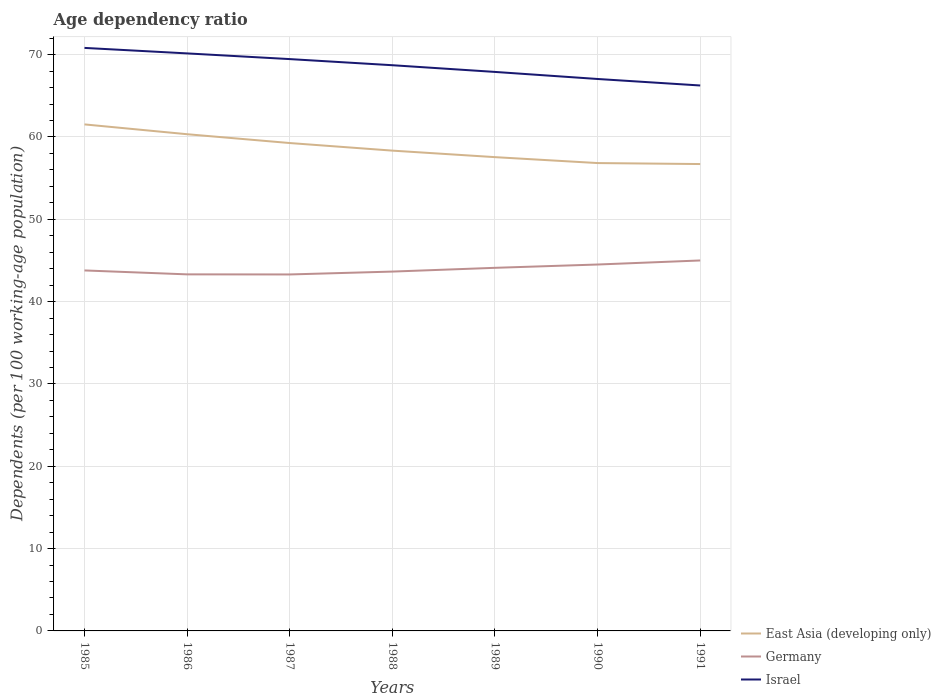How many different coloured lines are there?
Ensure brevity in your answer.  3. Does the line corresponding to Germany intersect with the line corresponding to Israel?
Give a very brief answer. No. Is the number of lines equal to the number of legend labels?
Give a very brief answer. Yes. Across all years, what is the maximum age dependency ratio in in Germany?
Your answer should be very brief. 43.3. In which year was the age dependency ratio in in East Asia (developing only) maximum?
Make the answer very short. 1991. What is the total age dependency ratio in in Germany in the graph?
Ensure brevity in your answer.  -1.2. What is the difference between the highest and the second highest age dependency ratio in in Germany?
Your response must be concise. 1.7. How many lines are there?
Keep it short and to the point. 3. What is the difference between two consecutive major ticks on the Y-axis?
Your response must be concise. 10. Does the graph contain any zero values?
Your answer should be very brief. No. Where does the legend appear in the graph?
Make the answer very short. Bottom right. How many legend labels are there?
Keep it short and to the point. 3. What is the title of the graph?
Keep it short and to the point. Age dependency ratio. Does "Low income" appear as one of the legend labels in the graph?
Offer a terse response. No. What is the label or title of the X-axis?
Offer a very short reply. Years. What is the label or title of the Y-axis?
Ensure brevity in your answer.  Dependents (per 100 working-age population). What is the Dependents (per 100 working-age population) of East Asia (developing only) in 1985?
Provide a short and direct response. 61.53. What is the Dependents (per 100 working-age population) of Germany in 1985?
Offer a very short reply. 43.79. What is the Dependents (per 100 working-age population) in Israel in 1985?
Your answer should be compact. 70.82. What is the Dependents (per 100 working-age population) of East Asia (developing only) in 1986?
Give a very brief answer. 60.33. What is the Dependents (per 100 working-age population) in Germany in 1986?
Your response must be concise. 43.31. What is the Dependents (per 100 working-age population) in Israel in 1986?
Your response must be concise. 70.15. What is the Dependents (per 100 working-age population) of East Asia (developing only) in 1987?
Provide a succinct answer. 59.26. What is the Dependents (per 100 working-age population) of Germany in 1987?
Keep it short and to the point. 43.3. What is the Dependents (per 100 working-age population) in Israel in 1987?
Your response must be concise. 69.46. What is the Dependents (per 100 working-age population) in East Asia (developing only) in 1988?
Provide a short and direct response. 58.34. What is the Dependents (per 100 working-age population) of Germany in 1988?
Your response must be concise. 43.65. What is the Dependents (per 100 working-age population) of Israel in 1988?
Keep it short and to the point. 68.72. What is the Dependents (per 100 working-age population) of East Asia (developing only) in 1989?
Provide a succinct answer. 57.55. What is the Dependents (per 100 working-age population) in Germany in 1989?
Provide a short and direct response. 44.11. What is the Dependents (per 100 working-age population) of Israel in 1989?
Provide a short and direct response. 67.9. What is the Dependents (per 100 working-age population) of East Asia (developing only) in 1990?
Offer a terse response. 56.83. What is the Dependents (per 100 working-age population) in Germany in 1990?
Your answer should be very brief. 44.51. What is the Dependents (per 100 working-age population) in Israel in 1990?
Provide a succinct answer. 67.04. What is the Dependents (per 100 working-age population) of East Asia (developing only) in 1991?
Give a very brief answer. 56.71. What is the Dependents (per 100 working-age population) in Germany in 1991?
Ensure brevity in your answer.  45. What is the Dependents (per 100 working-age population) of Israel in 1991?
Your answer should be compact. 66.26. Across all years, what is the maximum Dependents (per 100 working-age population) of East Asia (developing only)?
Keep it short and to the point. 61.53. Across all years, what is the maximum Dependents (per 100 working-age population) in Germany?
Provide a short and direct response. 45. Across all years, what is the maximum Dependents (per 100 working-age population) in Israel?
Keep it short and to the point. 70.82. Across all years, what is the minimum Dependents (per 100 working-age population) of East Asia (developing only)?
Your answer should be very brief. 56.71. Across all years, what is the minimum Dependents (per 100 working-age population) of Germany?
Ensure brevity in your answer.  43.3. Across all years, what is the minimum Dependents (per 100 working-age population) of Israel?
Ensure brevity in your answer.  66.26. What is the total Dependents (per 100 working-age population) of East Asia (developing only) in the graph?
Give a very brief answer. 410.56. What is the total Dependents (per 100 working-age population) in Germany in the graph?
Give a very brief answer. 307.66. What is the total Dependents (per 100 working-age population) of Israel in the graph?
Ensure brevity in your answer.  480.35. What is the difference between the Dependents (per 100 working-age population) in East Asia (developing only) in 1985 and that in 1986?
Offer a very short reply. 1.19. What is the difference between the Dependents (per 100 working-age population) of Germany in 1985 and that in 1986?
Provide a succinct answer. 0.48. What is the difference between the Dependents (per 100 working-age population) of Israel in 1985 and that in 1986?
Offer a terse response. 0.67. What is the difference between the Dependents (per 100 working-age population) in East Asia (developing only) in 1985 and that in 1987?
Your answer should be very brief. 2.26. What is the difference between the Dependents (per 100 working-age population) in Germany in 1985 and that in 1987?
Your response must be concise. 0.49. What is the difference between the Dependents (per 100 working-age population) in Israel in 1985 and that in 1987?
Provide a succinct answer. 1.36. What is the difference between the Dependents (per 100 working-age population) in East Asia (developing only) in 1985 and that in 1988?
Offer a very short reply. 3.19. What is the difference between the Dependents (per 100 working-age population) in Germany in 1985 and that in 1988?
Give a very brief answer. 0.14. What is the difference between the Dependents (per 100 working-age population) of Israel in 1985 and that in 1988?
Offer a very short reply. 2.1. What is the difference between the Dependents (per 100 working-age population) of East Asia (developing only) in 1985 and that in 1989?
Your answer should be very brief. 3.98. What is the difference between the Dependents (per 100 working-age population) in Germany in 1985 and that in 1989?
Your answer should be compact. -0.32. What is the difference between the Dependents (per 100 working-age population) in Israel in 1985 and that in 1989?
Offer a terse response. 2.92. What is the difference between the Dependents (per 100 working-age population) of East Asia (developing only) in 1985 and that in 1990?
Keep it short and to the point. 4.7. What is the difference between the Dependents (per 100 working-age population) in Germany in 1985 and that in 1990?
Provide a short and direct response. -0.72. What is the difference between the Dependents (per 100 working-age population) in Israel in 1985 and that in 1990?
Make the answer very short. 3.78. What is the difference between the Dependents (per 100 working-age population) of East Asia (developing only) in 1985 and that in 1991?
Provide a succinct answer. 4.81. What is the difference between the Dependents (per 100 working-age population) of Germany in 1985 and that in 1991?
Your answer should be compact. -1.21. What is the difference between the Dependents (per 100 working-age population) in Israel in 1985 and that in 1991?
Offer a terse response. 4.57. What is the difference between the Dependents (per 100 working-age population) in East Asia (developing only) in 1986 and that in 1987?
Offer a terse response. 1.07. What is the difference between the Dependents (per 100 working-age population) in Germany in 1986 and that in 1987?
Offer a very short reply. 0.01. What is the difference between the Dependents (per 100 working-age population) in Israel in 1986 and that in 1987?
Provide a succinct answer. 0.69. What is the difference between the Dependents (per 100 working-age population) of East Asia (developing only) in 1986 and that in 1988?
Make the answer very short. 1.99. What is the difference between the Dependents (per 100 working-age population) of Germany in 1986 and that in 1988?
Offer a terse response. -0.34. What is the difference between the Dependents (per 100 working-age population) in Israel in 1986 and that in 1988?
Make the answer very short. 1.44. What is the difference between the Dependents (per 100 working-age population) in East Asia (developing only) in 1986 and that in 1989?
Provide a succinct answer. 2.78. What is the difference between the Dependents (per 100 working-age population) of Germany in 1986 and that in 1989?
Provide a short and direct response. -0.8. What is the difference between the Dependents (per 100 working-age population) in Israel in 1986 and that in 1989?
Make the answer very short. 2.25. What is the difference between the Dependents (per 100 working-age population) of East Asia (developing only) in 1986 and that in 1990?
Your response must be concise. 3.5. What is the difference between the Dependents (per 100 working-age population) in Germany in 1986 and that in 1990?
Keep it short and to the point. -1.2. What is the difference between the Dependents (per 100 working-age population) in Israel in 1986 and that in 1990?
Ensure brevity in your answer.  3.11. What is the difference between the Dependents (per 100 working-age population) of East Asia (developing only) in 1986 and that in 1991?
Give a very brief answer. 3.62. What is the difference between the Dependents (per 100 working-age population) in Germany in 1986 and that in 1991?
Your answer should be compact. -1.69. What is the difference between the Dependents (per 100 working-age population) of Israel in 1986 and that in 1991?
Provide a short and direct response. 3.9. What is the difference between the Dependents (per 100 working-age population) of East Asia (developing only) in 1987 and that in 1988?
Your answer should be compact. 0.92. What is the difference between the Dependents (per 100 working-age population) in Germany in 1987 and that in 1988?
Give a very brief answer. -0.35. What is the difference between the Dependents (per 100 working-age population) of Israel in 1987 and that in 1988?
Give a very brief answer. 0.75. What is the difference between the Dependents (per 100 working-age population) of East Asia (developing only) in 1987 and that in 1989?
Ensure brevity in your answer.  1.71. What is the difference between the Dependents (per 100 working-age population) of Germany in 1987 and that in 1989?
Make the answer very short. -0.81. What is the difference between the Dependents (per 100 working-age population) of Israel in 1987 and that in 1989?
Provide a succinct answer. 1.56. What is the difference between the Dependents (per 100 working-age population) in East Asia (developing only) in 1987 and that in 1990?
Your answer should be very brief. 2.43. What is the difference between the Dependents (per 100 working-age population) in Germany in 1987 and that in 1990?
Your answer should be very brief. -1.21. What is the difference between the Dependents (per 100 working-age population) in Israel in 1987 and that in 1990?
Make the answer very short. 2.42. What is the difference between the Dependents (per 100 working-age population) in East Asia (developing only) in 1987 and that in 1991?
Offer a very short reply. 2.55. What is the difference between the Dependents (per 100 working-age population) of Germany in 1987 and that in 1991?
Offer a very short reply. -1.7. What is the difference between the Dependents (per 100 working-age population) of Israel in 1987 and that in 1991?
Ensure brevity in your answer.  3.21. What is the difference between the Dependents (per 100 working-age population) in East Asia (developing only) in 1988 and that in 1989?
Keep it short and to the point. 0.79. What is the difference between the Dependents (per 100 working-age population) in Germany in 1988 and that in 1989?
Give a very brief answer. -0.46. What is the difference between the Dependents (per 100 working-age population) of Israel in 1988 and that in 1989?
Provide a succinct answer. 0.81. What is the difference between the Dependents (per 100 working-age population) in East Asia (developing only) in 1988 and that in 1990?
Offer a terse response. 1.51. What is the difference between the Dependents (per 100 working-age population) in Germany in 1988 and that in 1990?
Make the answer very short. -0.86. What is the difference between the Dependents (per 100 working-age population) in Israel in 1988 and that in 1990?
Provide a short and direct response. 1.67. What is the difference between the Dependents (per 100 working-age population) in East Asia (developing only) in 1988 and that in 1991?
Your answer should be very brief. 1.63. What is the difference between the Dependents (per 100 working-age population) in Germany in 1988 and that in 1991?
Ensure brevity in your answer.  -1.35. What is the difference between the Dependents (per 100 working-age population) in Israel in 1988 and that in 1991?
Your answer should be compact. 2.46. What is the difference between the Dependents (per 100 working-age population) of East Asia (developing only) in 1989 and that in 1990?
Your response must be concise. 0.72. What is the difference between the Dependents (per 100 working-age population) in Germany in 1989 and that in 1990?
Give a very brief answer. -0.4. What is the difference between the Dependents (per 100 working-age population) in Israel in 1989 and that in 1990?
Your answer should be compact. 0.86. What is the difference between the Dependents (per 100 working-age population) in East Asia (developing only) in 1989 and that in 1991?
Keep it short and to the point. 0.84. What is the difference between the Dependents (per 100 working-age population) in Germany in 1989 and that in 1991?
Give a very brief answer. -0.89. What is the difference between the Dependents (per 100 working-age population) in Israel in 1989 and that in 1991?
Offer a terse response. 1.65. What is the difference between the Dependents (per 100 working-age population) in East Asia (developing only) in 1990 and that in 1991?
Keep it short and to the point. 0.12. What is the difference between the Dependents (per 100 working-age population) of Germany in 1990 and that in 1991?
Offer a very short reply. -0.49. What is the difference between the Dependents (per 100 working-age population) in Israel in 1990 and that in 1991?
Your answer should be compact. 0.79. What is the difference between the Dependents (per 100 working-age population) in East Asia (developing only) in 1985 and the Dependents (per 100 working-age population) in Germany in 1986?
Offer a terse response. 18.22. What is the difference between the Dependents (per 100 working-age population) of East Asia (developing only) in 1985 and the Dependents (per 100 working-age population) of Israel in 1986?
Your answer should be very brief. -8.62. What is the difference between the Dependents (per 100 working-age population) of Germany in 1985 and the Dependents (per 100 working-age population) of Israel in 1986?
Make the answer very short. -26.36. What is the difference between the Dependents (per 100 working-age population) of East Asia (developing only) in 1985 and the Dependents (per 100 working-age population) of Germany in 1987?
Offer a very short reply. 18.23. What is the difference between the Dependents (per 100 working-age population) in East Asia (developing only) in 1985 and the Dependents (per 100 working-age population) in Israel in 1987?
Give a very brief answer. -7.93. What is the difference between the Dependents (per 100 working-age population) in Germany in 1985 and the Dependents (per 100 working-age population) in Israel in 1987?
Provide a succinct answer. -25.67. What is the difference between the Dependents (per 100 working-age population) of East Asia (developing only) in 1985 and the Dependents (per 100 working-age population) of Germany in 1988?
Offer a very short reply. 17.88. What is the difference between the Dependents (per 100 working-age population) in East Asia (developing only) in 1985 and the Dependents (per 100 working-age population) in Israel in 1988?
Offer a very short reply. -7.19. What is the difference between the Dependents (per 100 working-age population) in Germany in 1985 and the Dependents (per 100 working-age population) in Israel in 1988?
Provide a short and direct response. -24.93. What is the difference between the Dependents (per 100 working-age population) of East Asia (developing only) in 1985 and the Dependents (per 100 working-age population) of Germany in 1989?
Provide a short and direct response. 17.42. What is the difference between the Dependents (per 100 working-age population) of East Asia (developing only) in 1985 and the Dependents (per 100 working-age population) of Israel in 1989?
Offer a terse response. -6.38. What is the difference between the Dependents (per 100 working-age population) in Germany in 1985 and the Dependents (per 100 working-age population) in Israel in 1989?
Your response must be concise. -24.11. What is the difference between the Dependents (per 100 working-age population) of East Asia (developing only) in 1985 and the Dependents (per 100 working-age population) of Germany in 1990?
Your answer should be very brief. 17.02. What is the difference between the Dependents (per 100 working-age population) in East Asia (developing only) in 1985 and the Dependents (per 100 working-age population) in Israel in 1990?
Your answer should be compact. -5.52. What is the difference between the Dependents (per 100 working-age population) in Germany in 1985 and the Dependents (per 100 working-age population) in Israel in 1990?
Offer a terse response. -23.26. What is the difference between the Dependents (per 100 working-age population) of East Asia (developing only) in 1985 and the Dependents (per 100 working-age population) of Germany in 1991?
Make the answer very short. 16.53. What is the difference between the Dependents (per 100 working-age population) of East Asia (developing only) in 1985 and the Dependents (per 100 working-age population) of Israel in 1991?
Keep it short and to the point. -4.73. What is the difference between the Dependents (per 100 working-age population) in Germany in 1985 and the Dependents (per 100 working-age population) in Israel in 1991?
Offer a very short reply. -22.47. What is the difference between the Dependents (per 100 working-age population) in East Asia (developing only) in 1986 and the Dependents (per 100 working-age population) in Germany in 1987?
Make the answer very short. 17.03. What is the difference between the Dependents (per 100 working-age population) in East Asia (developing only) in 1986 and the Dependents (per 100 working-age population) in Israel in 1987?
Your answer should be very brief. -9.13. What is the difference between the Dependents (per 100 working-age population) in Germany in 1986 and the Dependents (per 100 working-age population) in Israel in 1987?
Your answer should be compact. -26.15. What is the difference between the Dependents (per 100 working-age population) in East Asia (developing only) in 1986 and the Dependents (per 100 working-age population) in Germany in 1988?
Your response must be concise. 16.69. What is the difference between the Dependents (per 100 working-age population) of East Asia (developing only) in 1986 and the Dependents (per 100 working-age population) of Israel in 1988?
Keep it short and to the point. -8.38. What is the difference between the Dependents (per 100 working-age population) of Germany in 1986 and the Dependents (per 100 working-age population) of Israel in 1988?
Offer a very short reply. -25.41. What is the difference between the Dependents (per 100 working-age population) in East Asia (developing only) in 1986 and the Dependents (per 100 working-age population) in Germany in 1989?
Give a very brief answer. 16.23. What is the difference between the Dependents (per 100 working-age population) in East Asia (developing only) in 1986 and the Dependents (per 100 working-age population) in Israel in 1989?
Offer a terse response. -7.57. What is the difference between the Dependents (per 100 working-age population) in Germany in 1986 and the Dependents (per 100 working-age population) in Israel in 1989?
Offer a very short reply. -24.59. What is the difference between the Dependents (per 100 working-age population) of East Asia (developing only) in 1986 and the Dependents (per 100 working-age population) of Germany in 1990?
Provide a short and direct response. 15.83. What is the difference between the Dependents (per 100 working-age population) in East Asia (developing only) in 1986 and the Dependents (per 100 working-age population) in Israel in 1990?
Provide a succinct answer. -6.71. What is the difference between the Dependents (per 100 working-age population) of Germany in 1986 and the Dependents (per 100 working-age population) of Israel in 1990?
Your answer should be very brief. -23.73. What is the difference between the Dependents (per 100 working-age population) in East Asia (developing only) in 1986 and the Dependents (per 100 working-age population) in Germany in 1991?
Offer a terse response. 15.34. What is the difference between the Dependents (per 100 working-age population) of East Asia (developing only) in 1986 and the Dependents (per 100 working-age population) of Israel in 1991?
Ensure brevity in your answer.  -5.92. What is the difference between the Dependents (per 100 working-age population) of Germany in 1986 and the Dependents (per 100 working-age population) of Israel in 1991?
Keep it short and to the point. -22.94. What is the difference between the Dependents (per 100 working-age population) in East Asia (developing only) in 1987 and the Dependents (per 100 working-age population) in Germany in 1988?
Give a very brief answer. 15.61. What is the difference between the Dependents (per 100 working-age population) in East Asia (developing only) in 1987 and the Dependents (per 100 working-age population) in Israel in 1988?
Your answer should be compact. -9.45. What is the difference between the Dependents (per 100 working-age population) in Germany in 1987 and the Dependents (per 100 working-age population) in Israel in 1988?
Keep it short and to the point. -25.41. What is the difference between the Dependents (per 100 working-age population) in East Asia (developing only) in 1987 and the Dependents (per 100 working-age population) in Germany in 1989?
Keep it short and to the point. 15.16. What is the difference between the Dependents (per 100 working-age population) of East Asia (developing only) in 1987 and the Dependents (per 100 working-age population) of Israel in 1989?
Offer a very short reply. -8.64. What is the difference between the Dependents (per 100 working-age population) in Germany in 1987 and the Dependents (per 100 working-age population) in Israel in 1989?
Your answer should be very brief. -24.6. What is the difference between the Dependents (per 100 working-age population) of East Asia (developing only) in 1987 and the Dependents (per 100 working-age population) of Germany in 1990?
Ensure brevity in your answer.  14.76. What is the difference between the Dependents (per 100 working-age population) in East Asia (developing only) in 1987 and the Dependents (per 100 working-age population) in Israel in 1990?
Your response must be concise. -7.78. What is the difference between the Dependents (per 100 working-age population) of Germany in 1987 and the Dependents (per 100 working-age population) of Israel in 1990?
Offer a terse response. -23.74. What is the difference between the Dependents (per 100 working-age population) of East Asia (developing only) in 1987 and the Dependents (per 100 working-age population) of Germany in 1991?
Give a very brief answer. 14.26. What is the difference between the Dependents (per 100 working-age population) in East Asia (developing only) in 1987 and the Dependents (per 100 working-age population) in Israel in 1991?
Give a very brief answer. -6.99. What is the difference between the Dependents (per 100 working-age population) of Germany in 1987 and the Dependents (per 100 working-age population) of Israel in 1991?
Your response must be concise. -22.95. What is the difference between the Dependents (per 100 working-age population) of East Asia (developing only) in 1988 and the Dependents (per 100 working-age population) of Germany in 1989?
Your answer should be compact. 14.24. What is the difference between the Dependents (per 100 working-age population) in East Asia (developing only) in 1988 and the Dependents (per 100 working-age population) in Israel in 1989?
Offer a very short reply. -9.56. What is the difference between the Dependents (per 100 working-age population) in Germany in 1988 and the Dependents (per 100 working-age population) in Israel in 1989?
Your answer should be compact. -24.25. What is the difference between the Dependents (per 100 working-age population) in East Asia (developing only) in 1988 and the Dependents (per 100 working-age population) in Germany in 1990?
Provide a short and direct response. 13.84. What is the difference between the Dependents (per 100 working-age population) of East Asia (developing only) in 1988 and the Dependents (per 100 working-age population) of Israel in 1990?
Give a very brief answer. -8.7. What is the difference between the Dependents (per 100 working-age population) in Germany in 1988 and the Dependents (per 100 working-age population) in Israel in 1990?
Offer a terse response. -23.39. What is the difference between the Dependents (per 100 working-age population) of East Asia (developing only) in 1988 and the Dependents (per 100 working-age population) of Germany in 1991?
Provide a succinct answer. 13.34. What is the difference between the Dependents (per 100 working-age population) in East Asia (developing only) in 1988 and the Dependents (per 100 working-age population) in Israel in 1991?
Offer a terse response. -7.91. What is the difference between the Dependents (per 100 working-age population) of Germany in 1988 and the Dependents (per 100 working-age population) of Israel in 1991?
Provide a short and direct response. -22.61. What is the difference between the Dependents (per 100 working-age population) in East Asia (developing only) in 1989 and the Dependents (per 100 working-age population) in Germany in 1990?
Give a very brief answer. 13.04. What is the difference between the Dependents (per 100 working-age population) of East Asia (developing only) in 1989 and the Dependents (per 100 working-age population) of Israel in 1990?
Offer a terse response. -9.49. What is the difference between the Dependents (per 100 working-age population) of Germany in 1989 and the Dependents (per 100 working-age population) of Israel in 1990?
Offer a very short reply. -22.94. What is the difference between the Dependents (per 100 working-age population) in East Asia (developing only) in 1989 and the Dependents (per 100 working-age population) in Germany in 1991?
Your answer should be very brief. 12.55. What is the difference between the Dependents (per 100 working-age population) of East Asia (developing only) in 1989 and the Dependents (per 100 working-age population) of Israel in 1991?
Keep it short and to the point. -8.7. What is the difference between the Dependents (per 100 working-age population) in Germany in 1989 and the Dependents (per 100 working-age population) in Israel in 1991?
Give a very brief answer. -22.15. What is the difference between the Dependents (per 100 working-age population) in East Asia (developing only) in 1990 and the Dependents (per 100 working-age population) in Germany in 1991?
Your answer should be very brief. 11.83. What is the difference between the Dependents (per 100 working-age population) of East Asia (developing only) in 1990 and the Dependents (per 100 working-age population) of Israel in 1991?
Make the answer very short. -9.42. What is the difference between the Dependents (per 100 working-age population) in Germany in 1990 and the Dependents (per 100 working-age population) in Israel in 1991?
Provide a short and direct response. -21.75. What is the average Dependents (per 100 working-age population) in East Asia (developing only) per year?
Ensure brevity in your answer.  58.65. What is the average Dependents (per 100 working-age population) in Germany per year?
Ensure brevity in your answer.  43.95. What is the average Dependents (per 100 working-age population) of Israel per year?
Your response must be concise. 68.62. In the year 1985, what is the difference between the Dependents (per 100 working-age population) of East Asia (developing only) and Dependents (per 100 working-age population) of Germany?
Offer a very short reply. 17.74. In the year 1985, what is the difference between the Dependents (per 100 working-age population) in East Asia (developing only) and Dependents (per 100 working-age population) in Israel?
Your response must be concise. -9.29. In the year 1985, what is the difference between the Dependents (per 100 working-age population) of Germany and Dependents (per 100 working-age population) of Israel?
Your answer should be very brief. -27.03. In the year 1986, what is the difference between the Dependents (per 100 working-age population) of East Asia (developing only) and Dependents (per 100 working-age population) of Germany?
Ensure brevity in your answer.  17.02. In the year 1986, what is the difference between the Dependents (per 100 working-age population) of East Asia (developing only) and Dependents (per 100 working-age population) of Israel?
Keep it short and to the point. -9.82. In the year 1986, what is the difference between the Dependents (per 100 working-age population) in Germany and Dependents (per 100 working-age population) in Israel?
Keep it short and to the point. -26.84. In the year 1987, what is the difference between the Dependents (per 100 working-age population) in East Asia (developing only) and Dependents (per 100 working-age population) in Germany?
Your answer should be compact. 15.96. In the year 1987, what is the difference between the Dependents (per 100 working-age population) in East Asia (developing only) and Dependents (per 100 working-age population) in Israel?
Make the answer very short. -10.2. In the year 1987, what is the difference between the Dependents (per 100 working-age population) of Germany and Dependents (per 100 working-age population) of Israel?
Your answer should be compact. -26.16. In the year 1988, what is the difference between the Dependents (per 100 working-age population) in East Asia (developing only) and Dependents (per 100 working-age population) in Germany?
Provide a short and direct response. 14.69. In the year 1988, what is the difference between the Dependents (per 100 working-age population) in East Asia (developing only) and Dependents (per 100 working-age population) in Israel?
Your response must be concise. -10.37. In the year 1988, what is the difference between the Dependents (per 100 working-age population) of Germany and Dependents (per 100 working-age population) of Israel?
Provide a succinct answer. -25.07. In the year 1989, what is the difference between the Dependents (per 100 working-age population) of East Asia (developing only) and Dependents (per 100 working-age population) of Germany?
Provide a short and direct response. 13.44. In the year 1989, what is the difference between the Dependents (per 100 working-age population) in East Asia (developing only) and Dependents (per 100 working-age population) in Israel?
Your answer should be compact. -10.35. In the year 1989, what is the difference between the Dependents (per 100 working-age population) of Germany and Dependents (per 100 working-age population) of Israel?
Provide a short and direct response. -23.8. In the year 1990, what is the difference between the Dependents (per 100 working-age population) of East Asia (developing only) and Dependents (per 100 working-age population) of Germany?
Your answer should be compact. 12.32. In the year 1990, what is the difference between the Dependents (per 100 working-age population) of East Asia (developing only) and Dependents (per 100 working-age population) of Israel?
Your answer should be very brief. -10.21. In the year 1990, what is the difference between the Dependents (per 100 working-age population) in Germany and Dependents (per 100 working-age population) in Israel?
Make the answer very short. -22.54. In the year 1991, what is the difference between the Dependents (per 100 working-age population) of East Asia (developing only) and Dependents (per 100 working-age population) of Germany?
Keep it short and to the point. 11.71. In the year 1991, what is the difference between the Dependents (per 100 working-age population) in East Asia (developing only) and Dependents (per 100 working-age population) in Israel?
Your answer should be compact. -9.54. In the year 1991, what is the difference between the Dependents (per 100 working-age population) in Germany and Dependents (per 100 working-age population) in Israel?
Offer a terse response. -21.26. What is the ratio of the Dependents (per 100 working-age population) in East Asia (developing only) in 1985 to that in 1986?
Make the answer very short. 1.02. What is the ratio of the Dependents (per 100 working-age population) of Israel in 1985 to that in 1986?
Offer a very short reply. 1.01. What is the ratio of the Dependents (per 100 working-age population) of East Asia (developing only) in 1985 to that in 1987?
Your answer should be compact. 1.04. What is the ratio of the Dependents (per 100 working-age population) in Germany in 1985 to that in 1987?
Provide a succinct answer. 1.01. What is the ratio of the Dependents (per 100 working-age population) in Israel in 1985 to that in 1987?
Make the answer very short. 1.02. What is the ratio of the Dependents (per 100 working-age population) in East Asia (developing only) in 1985 to that in 1988?
Your answer should be compact. 1.05. What is the ratio of the Dependents (per 100 working-age population) of Germany in 1985 to that in 1988?
Provide a short and direct response. 1. What is the ratio of the Dependents (per 100 working-age population) in Israel in 1985 to that in 1988?
Make the answer very short. 1.03. What is the ratio of the Dependents (per 100 working-age population) of East Asia (developing only) in 1985 to that in 1989?
Ensure brevity in your answer.  1.07. What is the ratio of the Dependents (per 100 working-age population) of Israel in 1985 to that in 1989?
Your answer should be compact. 1.04. What is the ratio of the Dependents (per 100 working-age population) in East Asia (developing only) in 1985 to that in 1990?
Provide a short and direct response. 1.08. What is the ratio of the Dependents (per 100 working-age population) in Germany in 1985 to that in 1990?
Offer a very short reply. 0.98. What is the ratio of the Dependents (per 100 working-age population) in Israel in 1985 to that in 1990?
Offer a very short reply. 1.06. What is the ratio of the Dependents (per 100 working-age population) of East Asia (developing only) in 1985 to that in 1991?
Your answer should be very brief. 1.08. What is the ratio of the Dependents (per 100 working-age population) in Germany in 1985 to that in 1991?
Make the answer very short. 0.97. What is the ratio of the Dependents (per 100 working-age population) of Israel in 1985 to that in 1991?
Ensure brevity in your answer.  1.07. What is the ratio of the Dependents (per 100 working-age population) of East Asia (developing only) in 1986 to that in 1987?
Offer a terse response. 1.02. What is the ratio of the Dependents (per 100 working-age population) of East Asia (developing only) in 1986 to that in 1988?
Offer a terse response. 1.03. What is the ratio of the Dependents (per 100 working-age population) of Germany in 1986 to that in 1988?
Your answer should be compact. 0.99. What is the ratio of the Dependents (per 100 working-age population) in Israel in 1986 to that in 1988?
Your response must be concise. 1.02. What is the ratio of the Dependents (per 100 working-age population) of East Asia (developing only) in 1986 to that in 1989?
Offer a terse response. 1.05. What is the ratio of the Dependents (per 100 working-age population) in Germany in 1986 to that in 1989?
Provide a short and direct response. 0.98. What is the ratio of the Dependents (per 100 working-age population) in Israel in 1986 to that in 1989?
Give a very brief answer. 1.03. What is the ratio of the Dependents (per 100 working-age population) in East Asia (developing only) in 1986 to that in 1990?
Provide a short and direct response. 1.06. What is the ratio of the Dependents (per 100 working-age population) in Germany in 1986 to that in 1990?
Provide a succinct answer. 0.97. What is the ratio of the Dependents (per 100 working-age population) in Israel in 1986 to that in 1990?
Your answer should be compact. 1.05. What is the ratio of the Dependents (per 100 working-age population) of East Asia (developing only) in 1986 to that in 1991?
Your response must be concise. 1.06. What is the ratio of the Dependents (per 100 working-age population) in Germany in 1986 to that in 1991?
Your response must be concise. 0.96. What is the ratio of the Dependents (per 100 working-age population) in Israel in 1986 to that in 1991?
Your answer should be compact. 1.06. What is the ratio of the Dependents (per 100 working-age population) in East Asia (developing only) in 1987 to that in 1988?
Make the answer very short. 1.02. What is the ratio of the Dependents (per 100 working-age population) in Germany in 1987 to that in 1988?
Your response must be concise. 0.99. What is the ratio of the Dependents (per 100 working-age population) in Israel in 1987 to that in 1988?
Your answer should be compact. 1.01. What is the ratio of the Dependents (per 100 working-age population) in East Asia (developing only) in 1987 to that in 1989?
Provide a succinct answer. 1.03. What is the ratio of the Dependents (per 100 working-age population) in Germany in 1987 to that in 1989?
Your answer should be very brief. 0.98. What is the ratio of the Dependents (per 100 working-age population) of Israel in 1987 to that in 1989?
Provide a short and direct response. 1.02. What is the ratio of the Dependents (per 100 working-age population) of East Asia (developing only) in 1987 to that in 1990?
Ensure brevity in your answer.  1.04. What is the ratio of the Dependents (per 100 working-age population) of Germany in 1987 to that in 1990?
Provide a short and direct response. 0.97. What is the ratio of the Dependents (per 100 working-age population) in Israel in 1987 to that in 1990?
Your answer should be very brief. 1.04. What is the ratio of the Dependents (per 100 working-age population) in East Asia (developing only) in 1987 to that in 1991?
Provide a short and direct response. 1.04. What is the ratio of the Dependents (per 100 working-age population) of Germany in 1987 to that in 1991?
Your answer should be very brief. 0.96. What is the ratio of the Dependents (per 100 working-age population) in Israel in 1987 to that in 1991?
Your response must be concise. 1.05. What is the ratio of the Dependents (per 100 working-age population) in East Asia (developing only) in 1988 to that in 1989?
Make the answer very short. 1.01. What is the ratio of the Dependents (per 100 working-age population) of Germany in 1988 to that in 1989?
Keep it short and to the point. 0.99. What is the ratio of the Dependents (per 100 working-age population) in Israel in 1988 to that in 1989?
Provide a succinct answer. 1.01. What is the ratio of the Dependents (per 100 working-age population) in East Asia (developing only) in 1988 to that in 1990?
Provide a succinct answer. 1.03. What is the ratio of the Dependents (per 100 working-age population) in Germany in 1988 to that in 1990?
Your answer should be compact. 0.98. What is the ratio of the Dependents (per 100 working-age population) in Israel in 1988 to that in 1990?
Keep it short and to the point. 1.02. What is the ratio of the Dependents (per 100 working-age population) in East Asia (developing only) in 1988 to that in 1991?
Offer a very short reply. 1.03. What is the ratio of the Dependents (per 100 working-age population) of Germany in 1988 to that in 1991?
Make the answer very short. 0.97. What is the ratio of the Dependents (per 100 working-age population) of Israel in 1988 to that in 1991?
Give a very brief answer. 1.04. What is the ratio of the Dependents (per 100 working-age population) in East Asia (developing only) in 1989 to that in 1990?
Offer a very short reply. 1.01. What is the ratio of the Dependents (per 100 working-age population) in Germany in 1989 to that in 1990?
Provide a short and direct response. 0.99. What is the ratio of the Dependents (per 100 working-age population) in Israel in 1989 to that in 1990?
Your answer should be compact. 1.01. What is the ratio of the Dependents (per 100 working-age population) of East Asia (developing only) in 1989 to that in 1991?
Your answer should be compact. 1.01. What is the ratio of the Dependents (per 100 working-age population) in Germany in 1989 to that in 1991?
Offer a terse response. 0.98. What is the ratio of the Dependents (per 100 working-age population) of Israel in 1989 to that in 1991?
Ensure brevity in your answer.  1.02. What is the ratio of the Dependents (per 100 working-age population) of Israel in 1990 to that in 1991?
Your answer should be very brief. 1.01. What is the difference between the highest and the second highest Dependents (per 100 working-age population) in East Asia (developing only)?
Offer a very short reply. 1.19. What is the difference between the highest and the second highest Dependents (per 100 working-age population) in Germany?
Offer a very short reply. 0.49. What is the difference between the highest and the second highest Dependents (per 100 working-age population) in Israel?
Keep it short and to the point. 0.67. What is the difference between the highest and the lowest Dependents (per 100 working-age population) in East Asia (developing only)?
Ensure brevity in your answer.  4.81. What is the difference between the highest and the lowest Dependents (per 100 working-age population) of Germany?
Your response must be concise. 1.7. What is the difference between the highest and the lowest Dependents (per 100 working-age population) in Israel?
Offer a terse response. 4.57. 